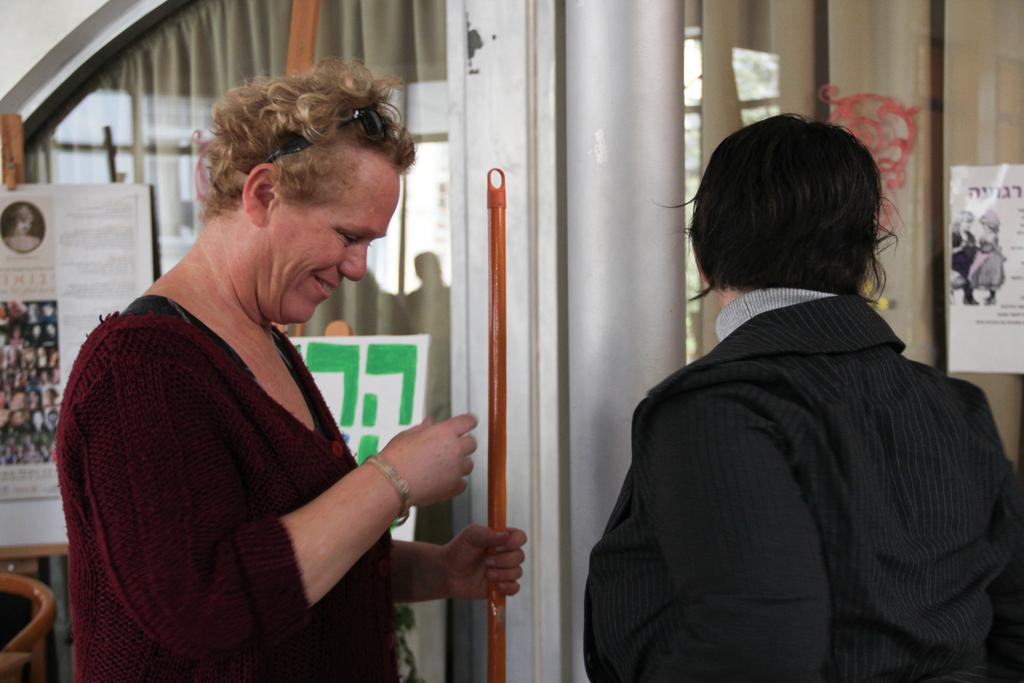How many people are in the image? There are two persons in the image. What is one of the persons holding? One of the persons is holding a stick. What can be seen on the mirrors in the image? There are posters on mirrors with text in the image. What type of window treatment is present in the image? There are curtains in the image. What type of structure is visible in the image? There is a wall visible in the image. What time is displayed on the clock in the image? There is no clock present in the image. What type of lipstick is the person wearing in the image? There is no lipstick or person wearing lipstick in the image. 